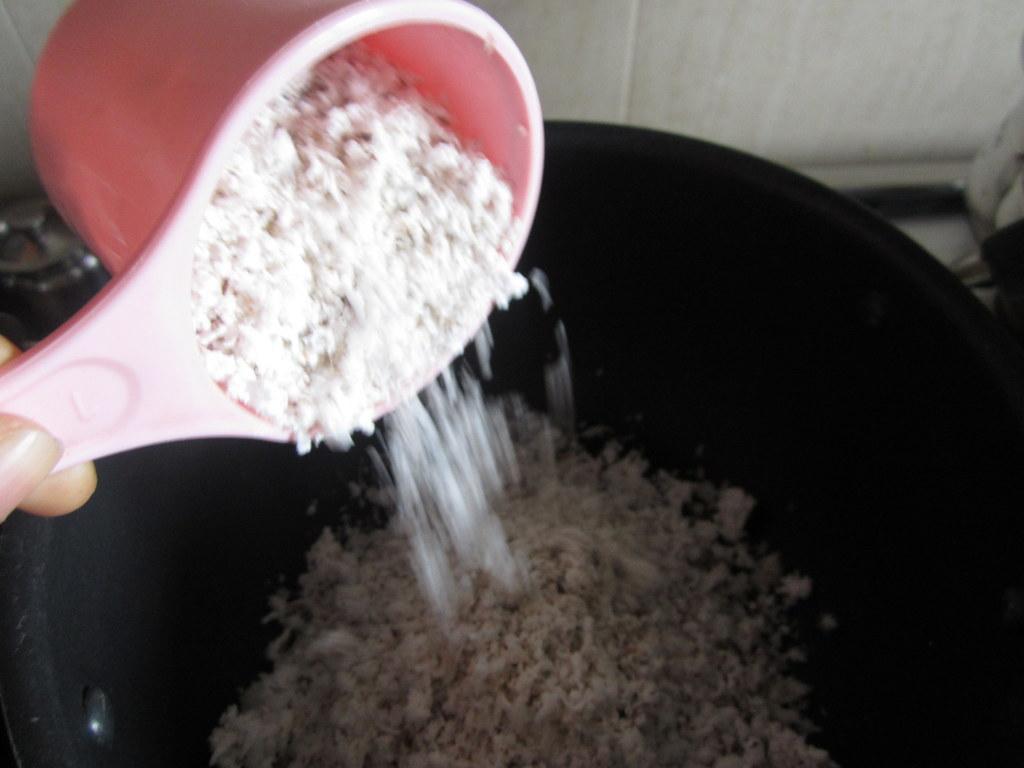How would you summarize this image in a sentence or two? In the center of the image a vessel contains food item. On the left side of the image we can see person hand and holding spoon. In the background of the image we can see wall, some vessels. 